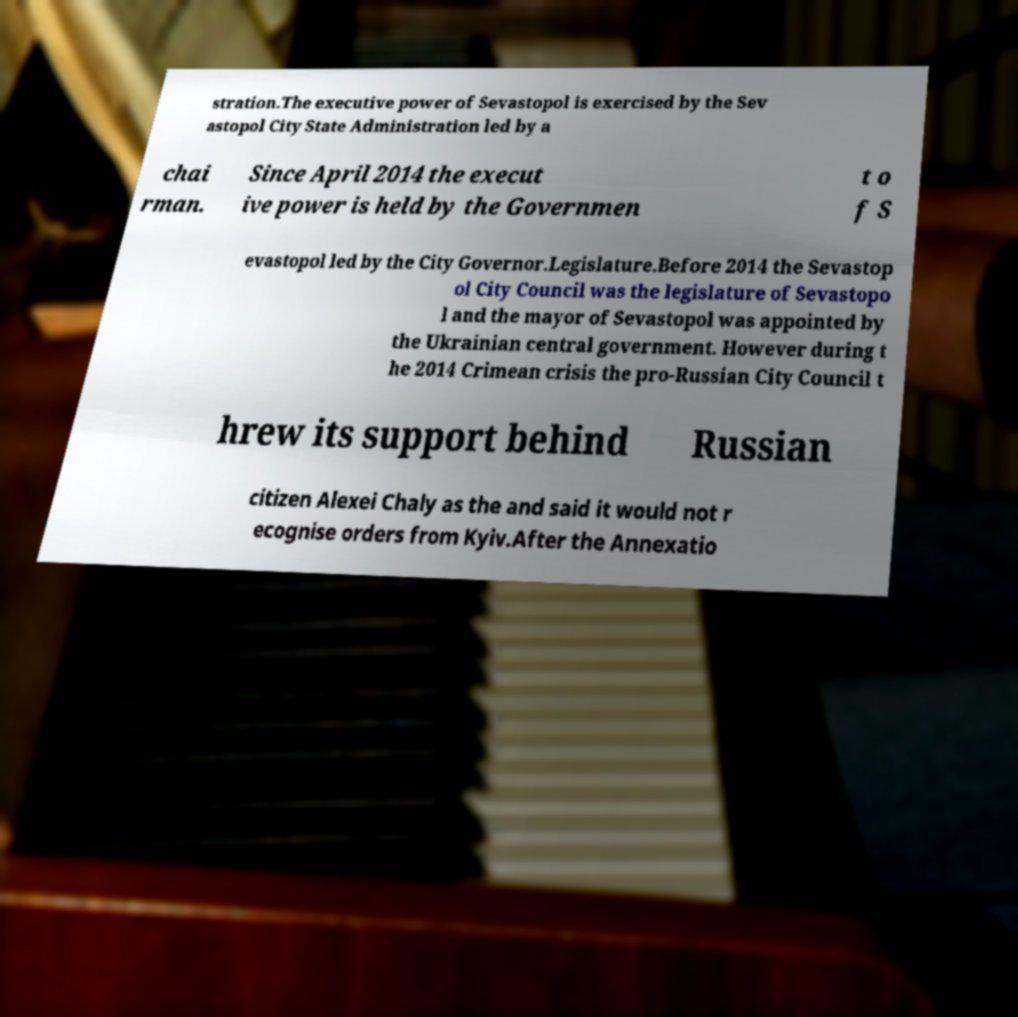Please identify and transcribe the text found in this image. stration.The executive power of Sevastopol is exercised by the Sev astopol City State Administration led by a chai rman. Since April 2014 the execut ive power is held by the Governmen t o f S evastopol led by the City Governor.Legislature.Before 2014 the Sevastop ol City Council was the legislature of Sevastopo l and the mayor of Sevastopol was appointed by the Ukrainian central government. However during t he 2014 Crimean crisis the pro-Russian City Council t hrew its support behind Russian citizen Alexei Chaly as the and said it would not r ecognise orders from Kyiv.After the Annexatio 